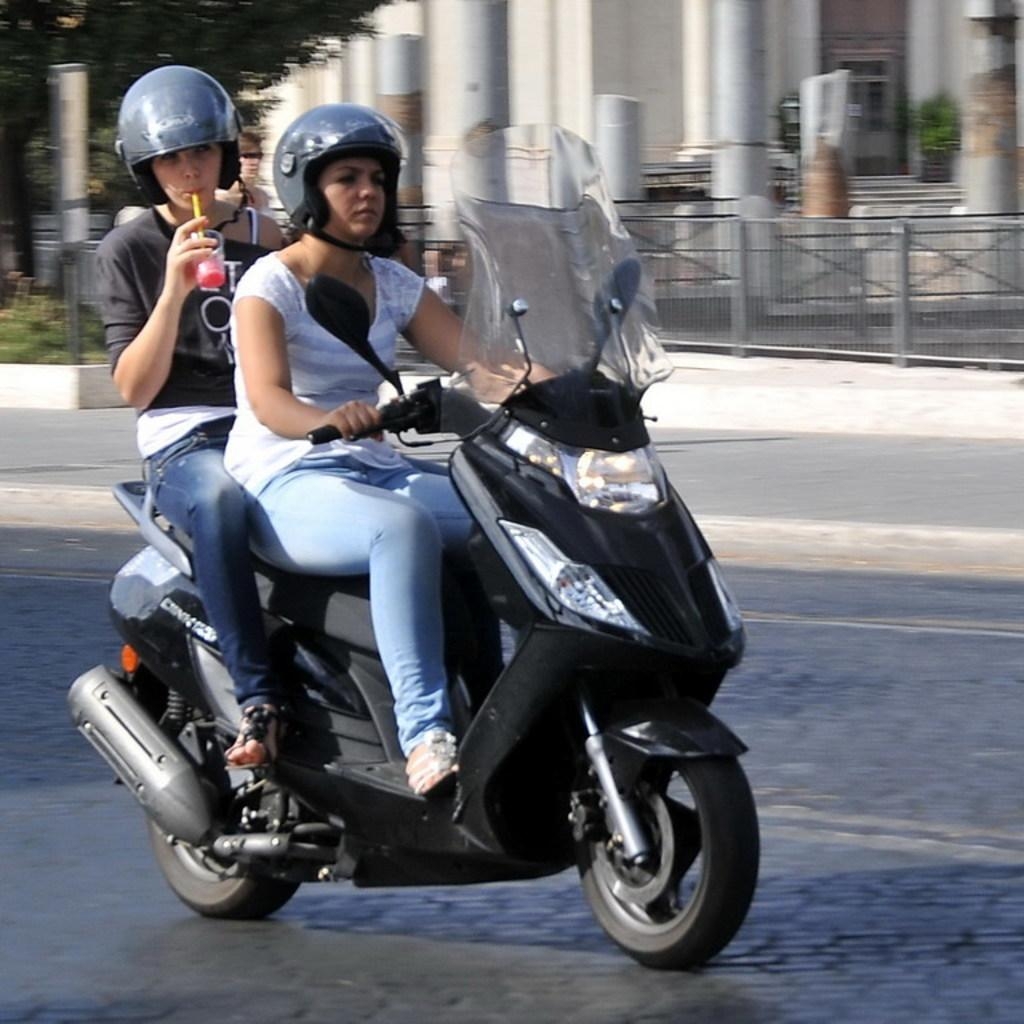Where was the image taken? The image is taken outdoors. How many people are in the image? There are two persons in the image. What are the persons doing in the image? The persons are sitting on a bike. What is the bike being ridden on? The bike is being ridden on a road. What can be seen in the background of the image? There is a pillar and a building visible in the background. What type of juice is being served at the table in the image? There is no table or juice present in the image; it features two persons sitting on a bike being ridden on a road. Who is the writer of the book being read by the person in the image? There is no book or person reading in the image; it features two persons sitting on a bike being ridden on a road. 